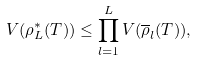Convert formula to latex. <formula><loc_0><loc_0><loc_500><loc_500>V ( \rho _ { L } ^ { * } ( T ) ) \leq \prod _ { l = 1 } ^ { L } V ( \overline { \rho } _ { l } ( T ) ) ,</formula> 